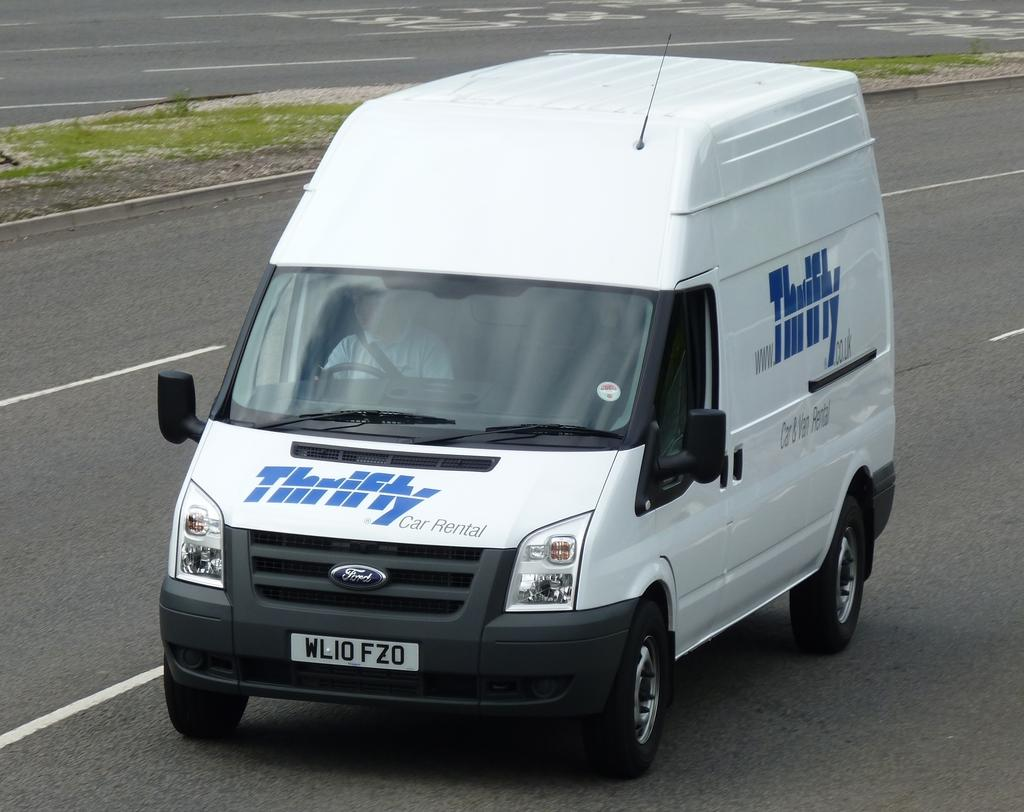<image>
Write a terse but informative summary of the picture. A white van with the words Thrifty written on it drives on the street 